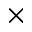<formula> <loc_0><loc_0><loc_500><loc_500>\times</formula> 